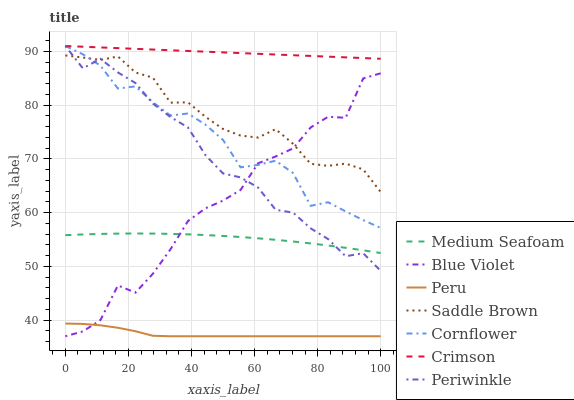Does Peru have the minimum area under the curve?
Answer yes or no. Yes. Does Crimson have the maximum area under the curve?
Answer yes or no. Yes. Does Saddle Brown have the minimum area under the curve?
Answer yes or no. No. Does Saddle Brown have the maximum area under the curve?
Answer yes or no. No. Is Crimson the smoothest?
Answer yes or no. Yes. Is Blue Violet the roughest?
Answer yes or no. Yes. Is Saddle Brown the smoothest?
Answer yes or no. No. Is Saddle Brown the roughest?
Answer yes or no. No. Does Peru have the lowest value?
Answer yes or no. Yes. Does Saddle Brown have the lowest value?
Answer yes or no. No. Does Crimson have the highest value?
Answer yes or no. Yes. Does Saddle Brown have the highest value?
Answer yes or no. No. Is Blue Violet less than Crimson?
Answer yes or no. Yes. Is Crimson greater than Saddle Brown?
Answer yes or no. Yes. Does Cornflower intersect Crimson?
Answer yes or no. Yes. Is Cornflower less than Crimson?
Answer yes or no. No. Is Cornflower greater than Crimson?
Answer yes or no. No. Does Blue Violet intersect Crimson?
Answer yes or no. No. 